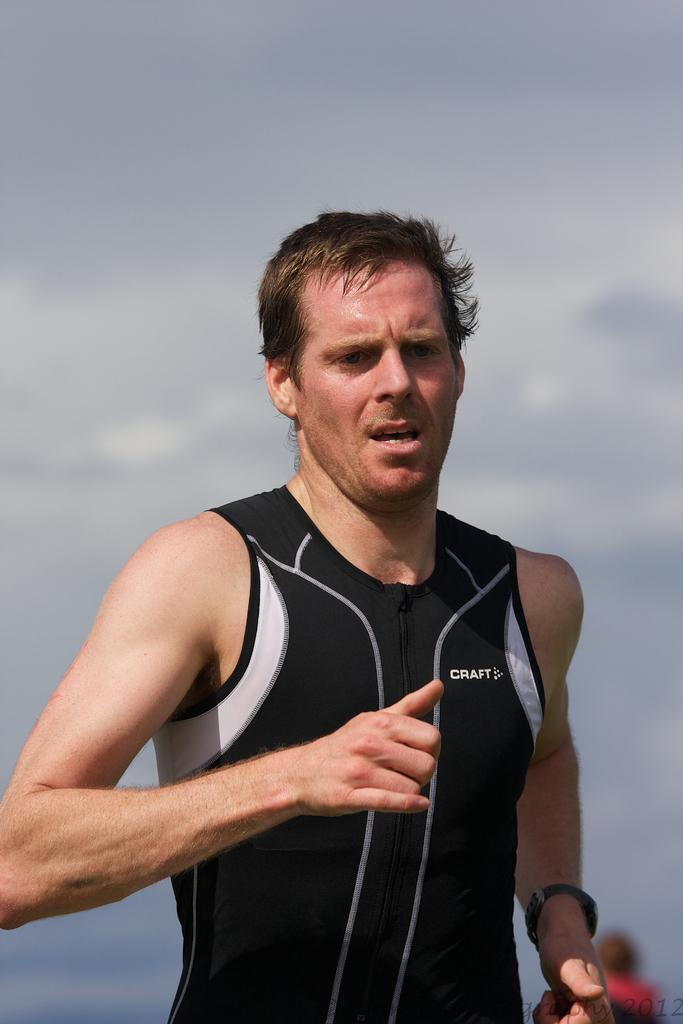Provide a one-sentence caption for the provided image. The runner looks tired in his black Craft tank top. 